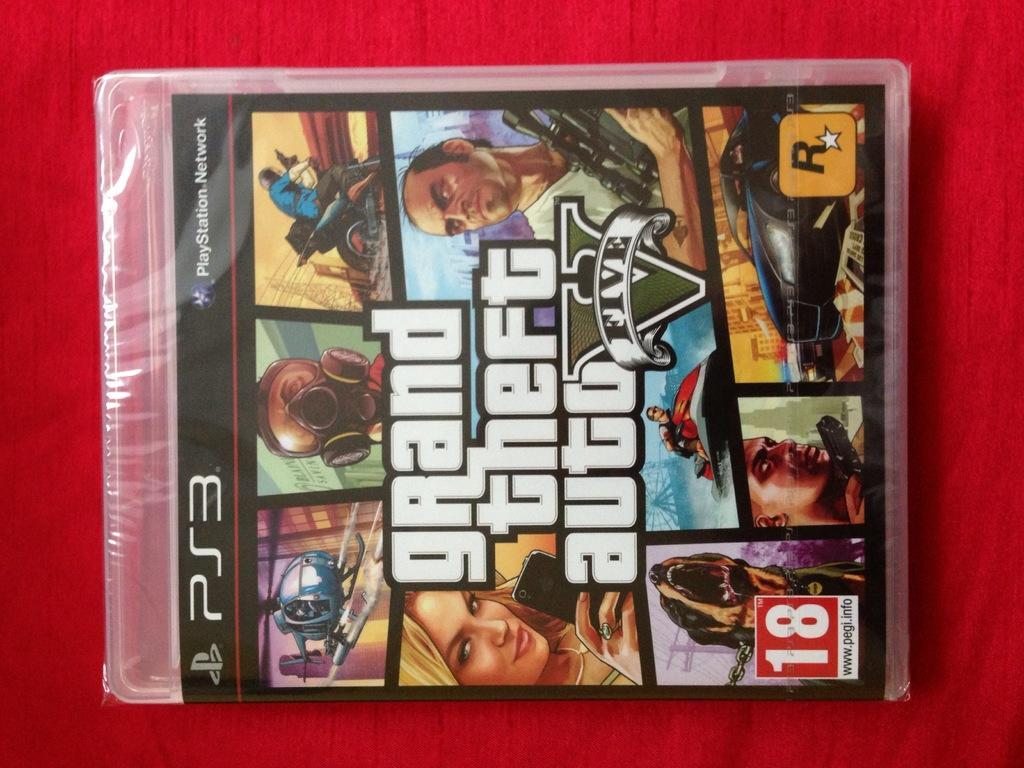How would you summarize this image in a sentence or two? This is zoomed in picture. In the center there is an object seems to be a box on which we can see the pictures of vehicles. On the left there is a man riding a bike and there is a woman holding a mobile phone and we can see a person holding a rifle and some other pictures and the text is printed on the box. The background of the image is red in color. 